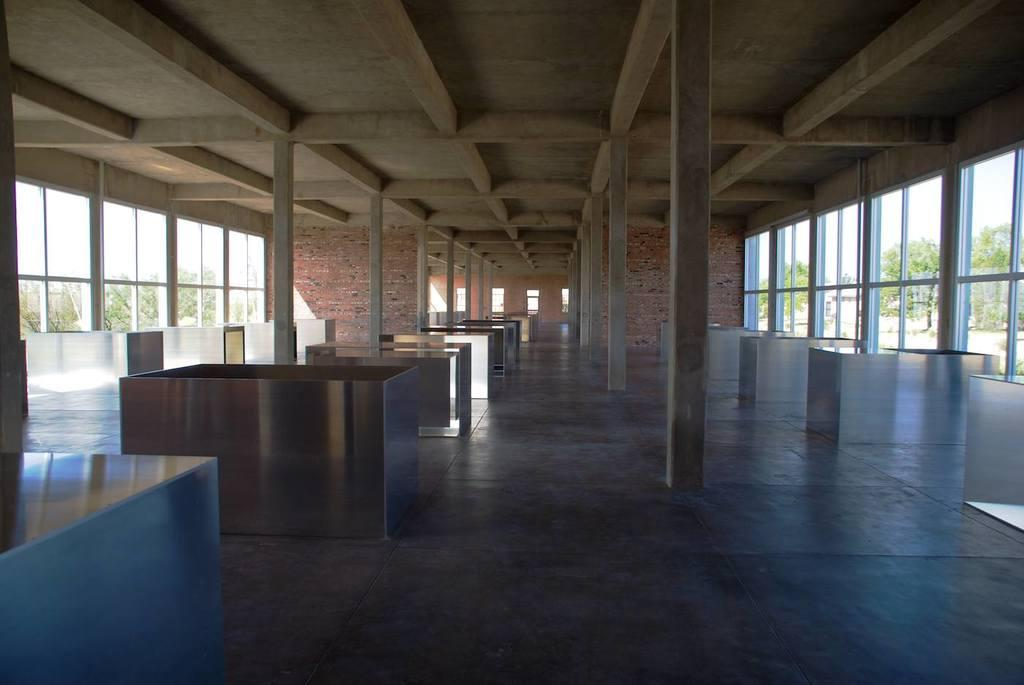What can be seen under the objects in the image? The floor is visible in the image. What architectural features are present in the image? There are pillars in the image. What is the primary purpose of the walls in the image? The walls are present in the image to enclose the space. What is the uppermost part of the structure visible in the image? The roof is visible in the image. What allows light to enter the space in the image? There are windows in the image. What can be seen in the background of the image? Trees and the sky are visible in the background of the image. What type of record is being played in the image? There is no record player or record visible in the image. 